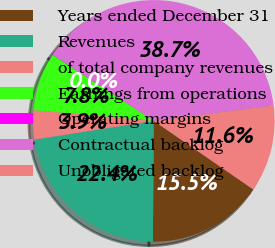Convert chart to OTSL. <chart><loc_0><loc_0><loc_500><loc_500><pie_chart><fcel>Years ended December 31<fcel>Revenues<fcel>of total company revenues<fcel>Earnings from operations<fcel>Operating margins<fcel>Contractual backlog<fcel>Unobligated backlog<nl><fcel>15.51%<fcel>22.41%<fcel>3.9%<fcel>7.77%<fcel>0.03%<fcel>38.74%<fcel>11.64%<nl></chart> 